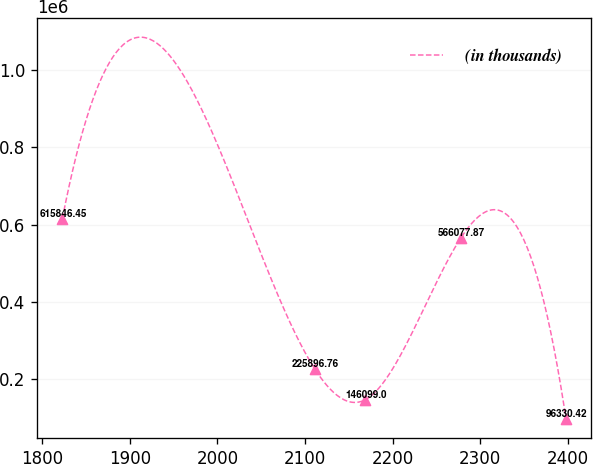Convert chart. <chart><loc_0><loc_0><loc_500><loc_500><line_chart><ecel><fcel>(in thousands)<nl><fcel>1823.17<fcel>615846<nl><fcel>2111.14<fcel>225897<nl><fcel>2168.6<fcel>146099<nl><fcel>2277.92<fcel>566078<nl><fcel>2397.73<fcel>96330.4<nl></chart> 